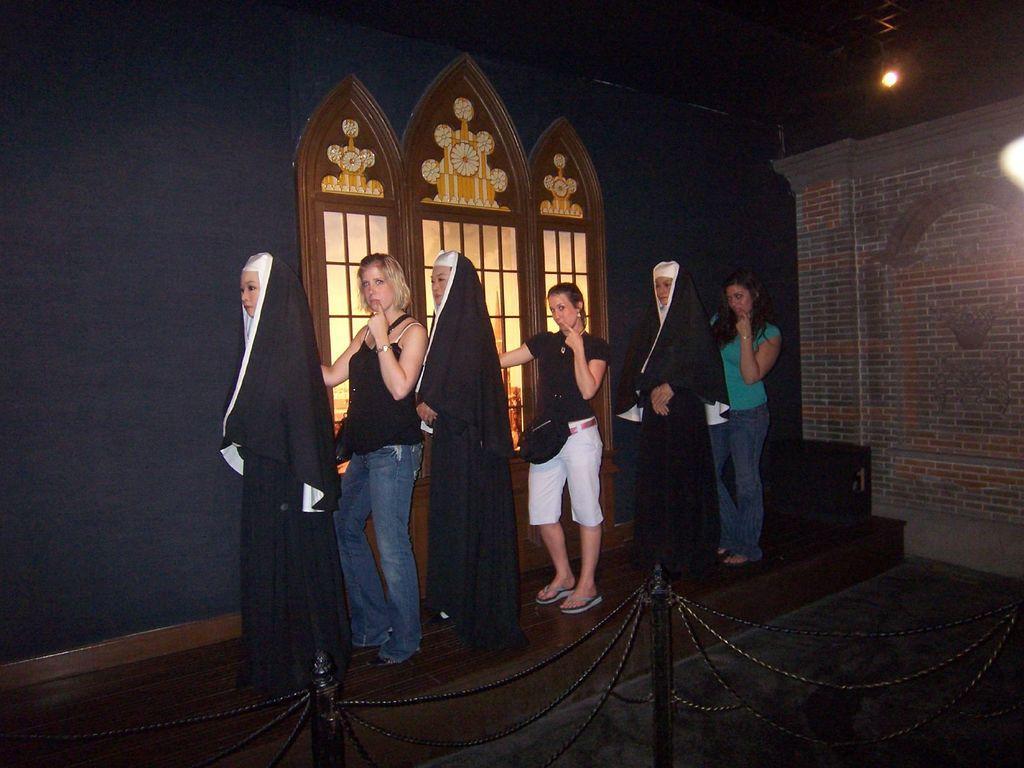Can you describe this image briefly? In the foreground of the picture there is a railing. In the center of the picture there are women and statues. In the background there are windows. On the right there are lights and wall. 